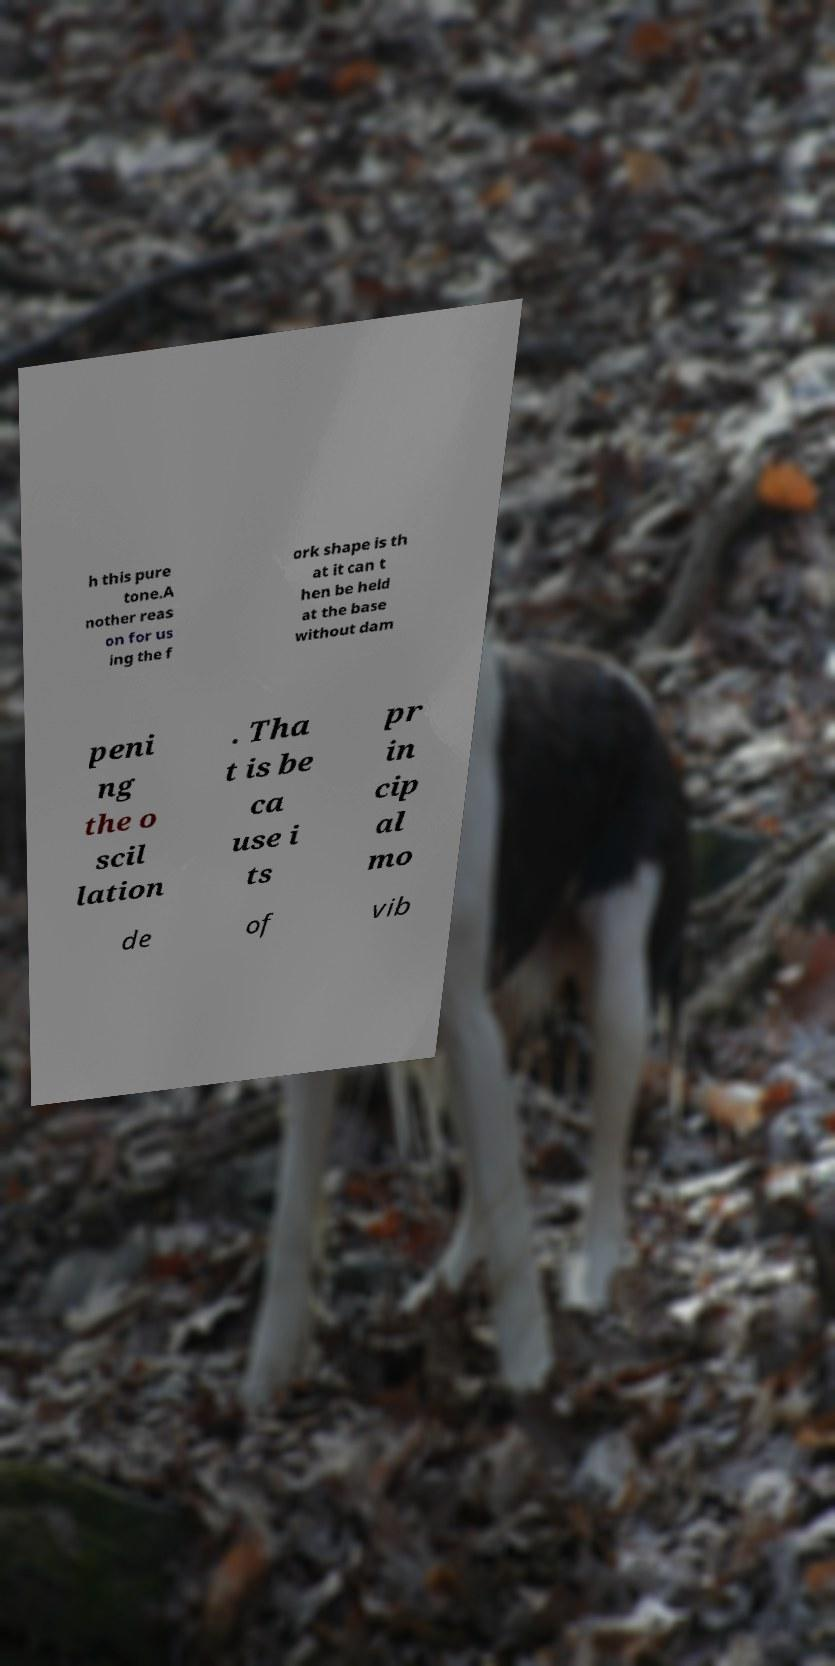I need the written content from this picture converted into text. Can you do that? h this pure tone.A nother reas on for us ing the f ork shape is th at it can t hen be held at the base without dam peni ng the o scil lation . Tha t is be ca use i ts pr in cip al mo de of vib 